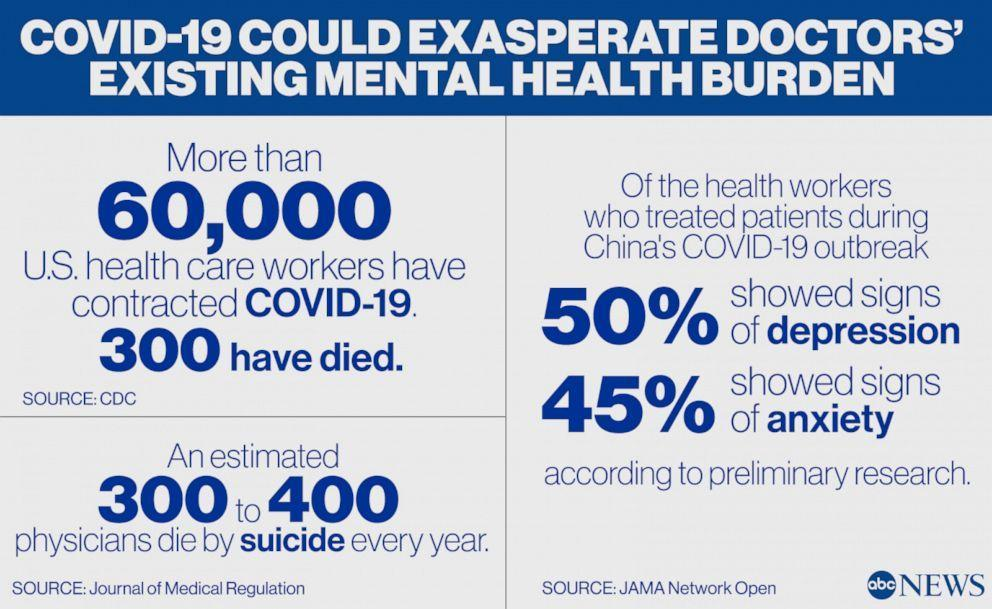What percentage of the health workers who treated patients during china's COVID-19 outbreak has showed signs of depression?
Answer the question with a short phrase. 50% What percentage of the health workers who treated patients during china's COVID-19 outbreak has showed signs of anxiety? 45% 